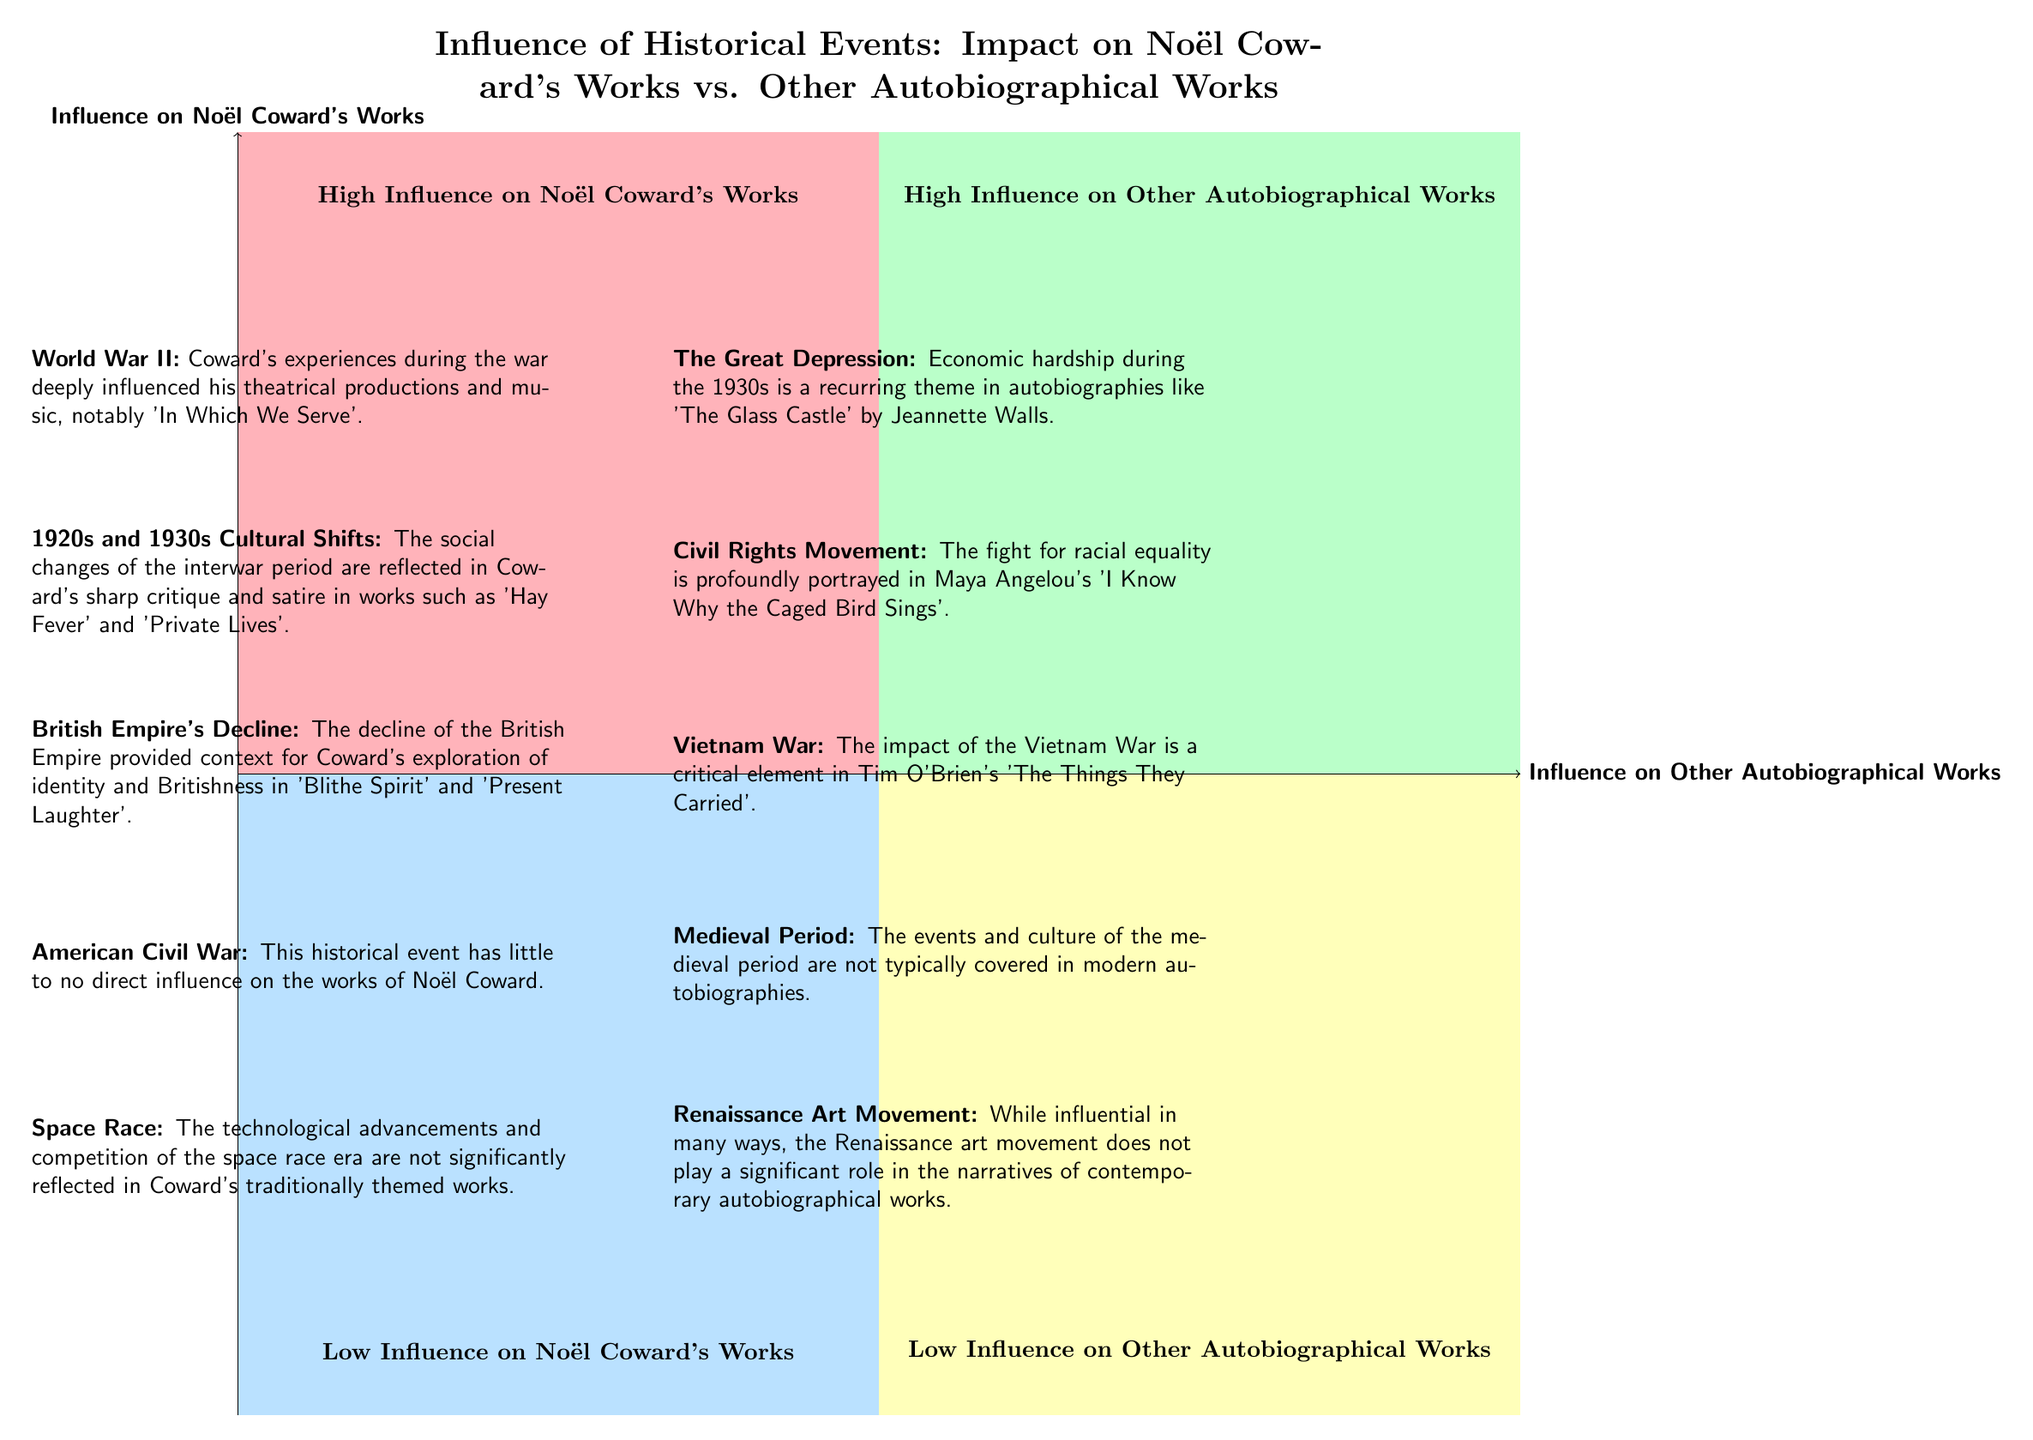What are the three elements in the "High Influence on Noël Coward's Works" quadrant? The quadrant contains three specific historical events: "World War II", "1920s and 1930s Cultural Shifts," and "British Empire's Decline."
Answer: World War II, 1920s and 1930s Cultural Shifts, British Empire's Decline How many elements are in the "Low Influence on Other Autobiographical Works" quadrant? This quadrant has two elements listed: "Medieval Period" and "Renaissance Art Movement." Therefore, the total count is two.
Answer: 2 Which historical event has a high influence on autobiographical works but low influence on Noël Coward's works? The "Civil Rights Movement" is indicated as having a high influence on autobiographical works but not affecting Noël Coward's works significantly.
Answer: Civil Rights Movement What is the description associated with "The Great Depression"? The description states that economic hardship during the 1930s is a recurring theme in autobiographies like "The Glass Castle" by Jeannette Walls.
Answer: Economic hardship during the 1930s is a recurring theme in autobiographies like "The Glass Castle." Which quadrant contains "American Civil War"? The "American Civil War" is categorized under the "Low Influence on Noël Coward's Works" quadrant.
Answer: Low Influence on Noël Coward's Works How does the influence of the Vietnam War compare between Noël Coward's works and other autobiographical works? The Vietnam War is categorized as having a high influence on other autobiographical works but is not a factor in Noël Coward's works, placing it in the high influence quadrant for autobiographies.
Answer: High influence on other autobiographical works Which two historical events in the “Low Influence on Other Autobiographical Works” quadrant are not commonly covered? The events "Medieval Period" and "Renaissance Art Movement" are listed as not typically covered in modern autobiographies, indicating a low influence on them.
Answer: Medieval Period, Renaissance Art Movement What kind of historical events does Noël Coward’s works reflect according to the diagram? Noël Coward's works reflect significant historical events like World War II, cultural shifts of the 1920s and 1930s, and the decline of the British Empire, indicating high influence.
Answer: Significant historical events like World War II, cultural shifts of the 1920s and 1930s, and decline of the British Empire 